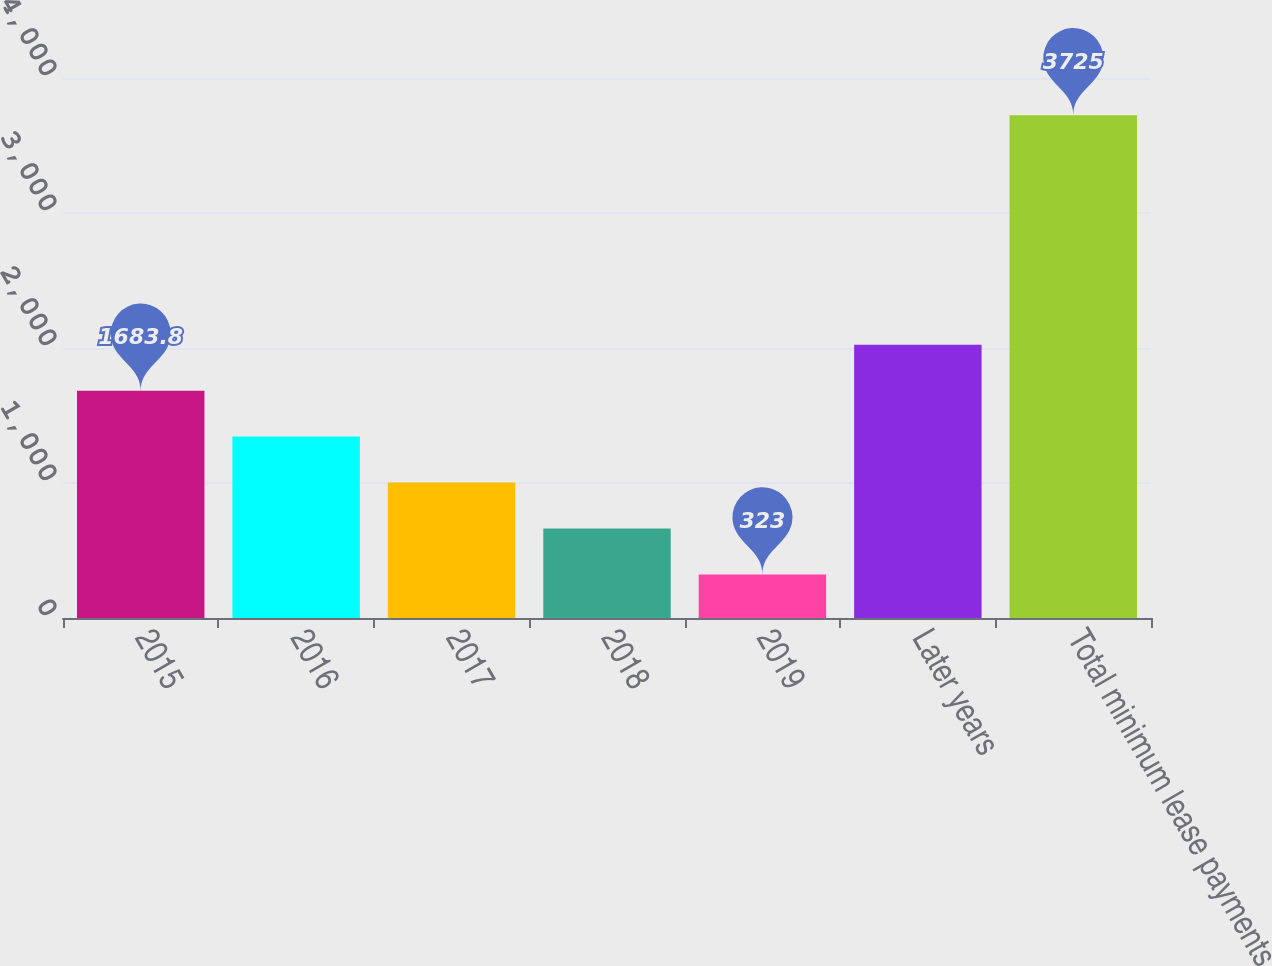Convert chart to OTSL. <chart><loc_0><loc_0><loc_500><loc_500><bar_chart><fcel>2015<fcel>2016<fcel>2017<fcel>2018<fcel>2019<fcel>Later years<fcel>Total minimum lease payments<nl><fcel>1683.8<fcel>1343.6<fcel>1003.4<fcel>663.2<fcel>323<fcel>2024<fcel>3725<nl></chart> 